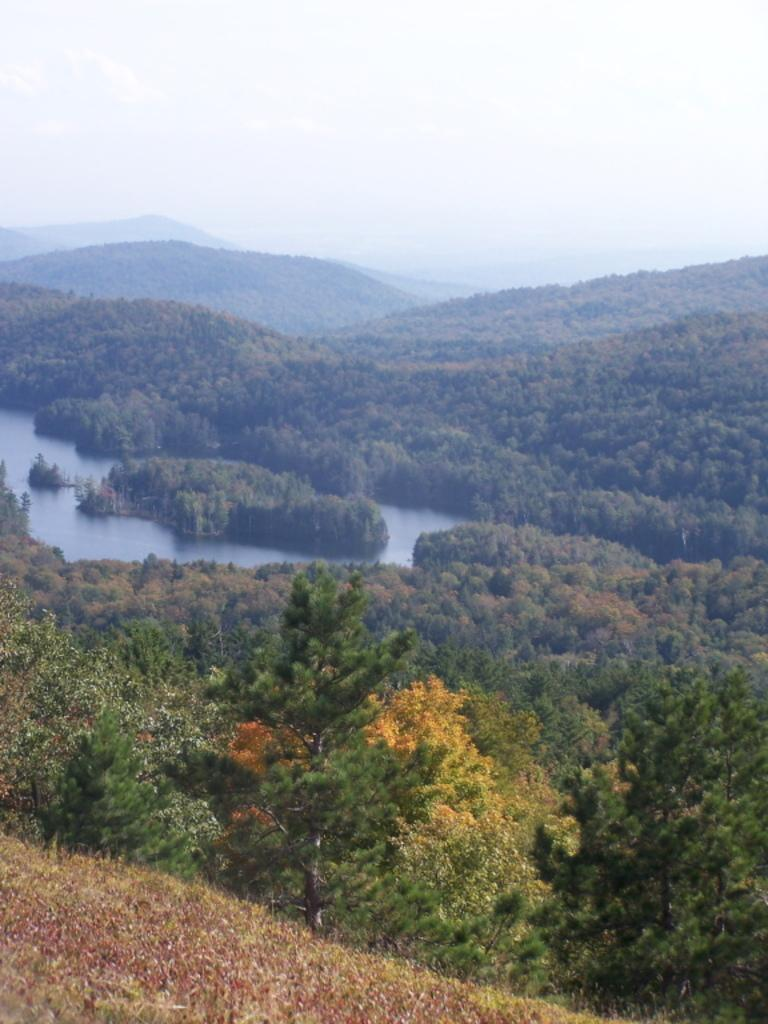What type of natural environment is depicted in the image? There is a forest in the image. Can you describe any specific features within the forest? There is a yellow color plant hire in the forest. What body of water can be seen in the image? There is a lake visible between the trees in the image. What can be seen in the distance behind the forest? There are hills in the background of the image. What is visible above the forest and hills? The sky is visible in the background of the image. How many thumbs are visible in the image? There are no thumbs visible in the image, as it depicts a forest scene with no human presence. What process is being carried out by the birds in the image? There are no birds present in the image, so no process can be observed. 